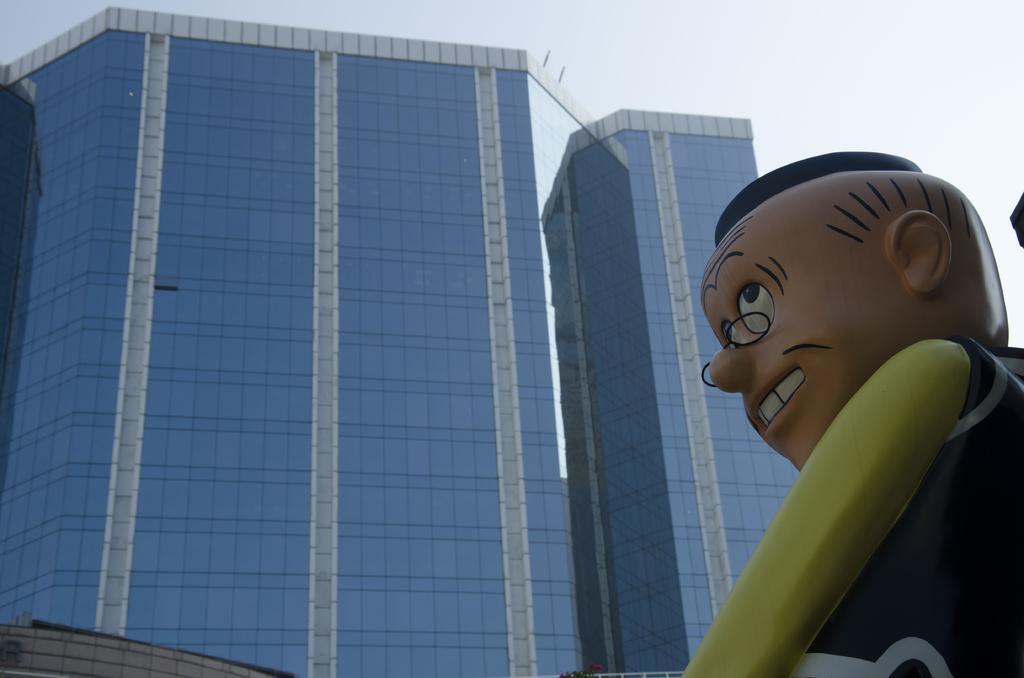Could you give a brief overview of what you see in this image? In this image I can see the statue of the person. It is in black and green color. In the back I can see the blue color building and the white sky. 